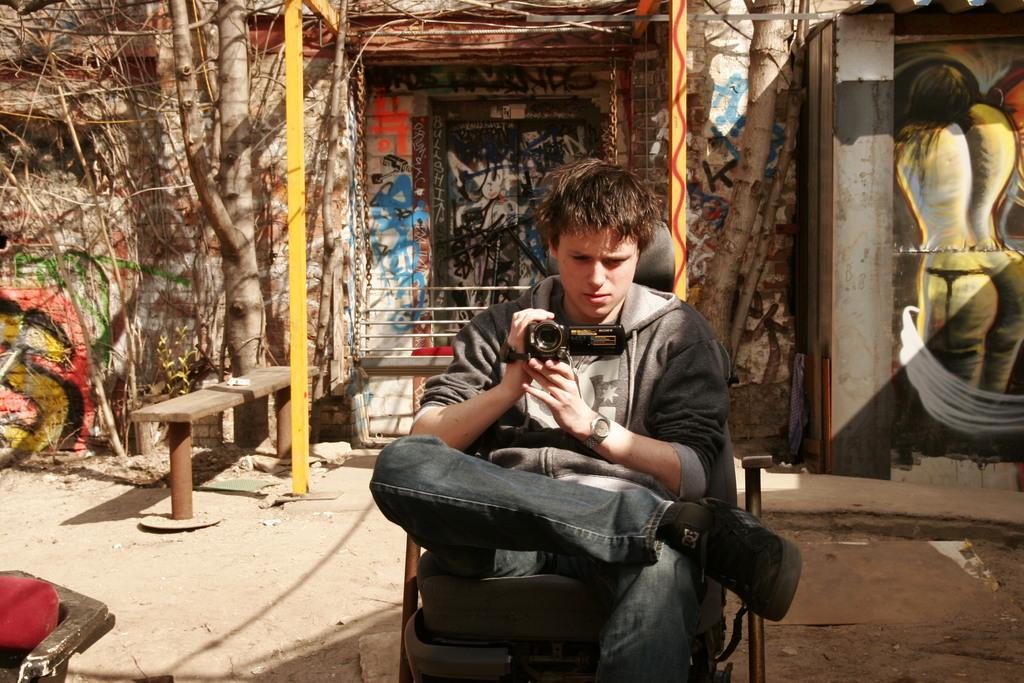Can you describe this image briefly? As we can see in the image there is a wall, bench, tree and a person sitting on chair and holding camera in his hand. 